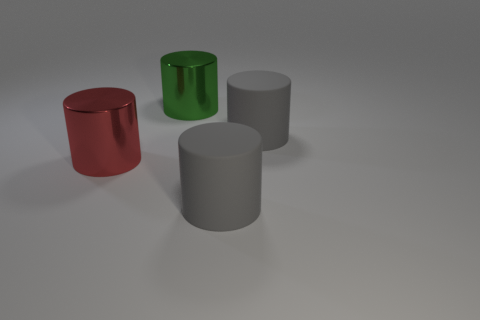Are there an equal number of large red metallic things that are to the left of the green shiny object and big things on the right side of the red metallic object?
Offer a very short reply. No. What number of other objects are the same material as the green cylinder?
Ensure brevity in your answer.  1. What number of tiny objects are either matte objects or red matte cubes?
Give a very brief answer. 0. Are there the same number of green cylinders behind the green cylinder and big yellow rubber cubes?
Provide a succinct answer. Yes. Are there any green metal cylinders in front of the big rubber object behind the big red object?
Keep it short and to the point. No. How many objects are large objects in front of the red shiny thing or metallic cylinders?
Provide a short and direct response. 3. There is a large red thing that is made of the same material as the green cylinder; what is its shape?
Provide a succinct answer. Cylinder. What color is the cylinder that is both on the right side of the green cylinder and behind the large red object?
Give a very brief answer. Gray. What shape is the green metal thing that is the same size as the red cylinder?
Offer a very short reply. Cylinder. Are there any gray things that have the same shape as the green shiny thing?
Provide a succinct answer. Yes. 